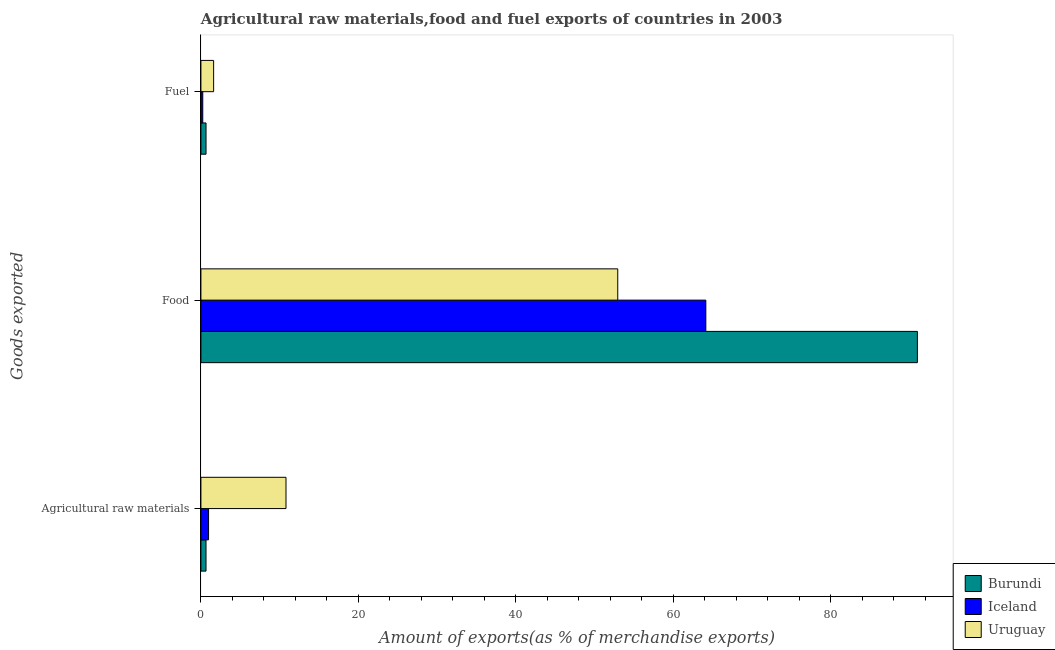How many groups of bars are there?
Provide a short and direct response. 3. How many bars are there on the 1st tick from the top?
Provide a succinct answer. 3. How many bars are there on the 3rd tick from the bottom?
Your response must be concise. 3. What is the label of the 1st group of bars from the top?
Offer a very short reply. Fuel. What is the percentage of fuel exports in Burundi?
Make the answer very short. 0.65. Across all countries, what is the maximum percentage of food exports?
Make the answer very short. 91.03. Across all countries, what is the minimum percentage of raw materials exports?
Provide a succinct answer. 0.65. In which country was the percentage of fuel exports maximum?
Your answer should be compact. Uruguay. In which country was the percentage of raw materials exports minimum?
Your response must be concise. Burundi. What is the total percentage of raw materials exports in the graph?
Make the answer very short. 12.43. What is the difference between the percentage of fuel exports in Uruguay and that in Burundi?
Your answer should be compact. 0.97. What is the difference between the percentage of fuel exports in Iceland and the percentage of raw materials exports in Uruguay?
Make the answer very short. -10.58. What is the average percentage of raw materials exports per country?
Make the answer very short. 4.14. What is the difference between the percentage of raw materials exports and percentage of fuel exports in Iceland?
Provide a succinct answer. 0.74. In how many countries, is the percentage of food exports greater than 84 %?
Give a very brief answer. 1. What is the ratio of the percentage of fuel exports in Iceland to that in Burundi?
Ensure brevity in your answer.  0.36. Is the percentage of raw materials exports in Burundi less than that in Uruguay?
Offer a very short reply. Yes. Is the difference between the percentage of fuel exports in Uruguay and Iceland greater than the difference between the percentage of food exports in Uruguay and Iceland?
Your answer should be very brief. Yes. What is the difference between the highest and the second highest percentage of fuel exports?
Provide a short and direct response. 0.97. What is the difference between the highest and the lowest percentage of food exports?
Make the answer very short. 38.07. What does the 3rd bar from the top in Fuel represents?
Keep it short and to the point. Burundi. What does the 1st bar from the bottom in Agricultural raw materials represents?
Give a very brief answer. Burundi. Is it the case that in every country, the sum of the percentage of raw materials exports and percentage of food exports is greater than the percentage of fuel exports?
Offer a very short reply. Yes. Are the values on the major ticks of X-axis written in scientific E-notation?
Make the answer very short. No. Does the graph contain any zero values?
Your response must be concise. No. How many legend labels are there?
Offer a terse response. 3. What is the title of the graph?
Make the answer very short. Agricultural raw materials,food and fuel exports of countries in 2003. Does "Cayman Islands" appear as one of the legend labels in the graph?
Your answer should be compact. No. What is the label or title of the X-axis?
Offer a very short reply. Amount of exports(as % of merchandise exports). What is the label or title of the Y-axis?
Ensure brevity in your answer.  Goods exported. What is the Amount of exports(as % of merchandise exports) in Burundi in Agricultural raw materials?
Make the answer very short. 0.65. What is the Amount of exports(as % of merchandise exports) of Iceland in Agricultural raw materials?
Make the answer very short. 0.97. What is the Amount of exports(as % of merchandise exports) of Uruguay in Agricultural raw materials?
Ensure brevity in your answer.  10.81. What is the Amount of exports(as % of merchandise exports) in Burundi in Food?
Offer a very short reply. 91.03. What is the Amount of exports(as % of merchandise exports) of Iceland in Food?
Offer a very short reply. 64.15. What is the Amount of exports(as % of merchandise exports) of Uruguay in Food?
Give a very brief answer. 52.96. What is the Amount of exports(as % of merchandise exports) in Burundi in Fuel?
Provide a succinct answer. 0.65. What is the Amount of exports(as % of merchandise exports) of Iceland in Fuel?
Your answer should be very brief. 0.23. What is the Amount of exports(as % of merchandise exports) in Uruguay in Fuel?
Your answer should be compact. 1.62. Across all Goods exported, what is the maximum Amount of exports(as % of merchandise exports) in Burundi?
Offer a very short reply. 91.03. Across all Goods exported, what is the maximum Amount of exports(as % of merchandise exports) in Iceland?
Provide a succinct answer. 64.15. Across all Goods exported, what is the maximum Amount of exports(as % of merchandise exports) of Uruguay?
Make the answer very short. 52.96. Across all Goods exported, what is the minimum Amount of exports(as % of merchandise exports) in Burundi?
Ensure brevity in your answer.  0.65. Across all Goods exported, what is the minimum Amount of exports(as % of merchandise exports) in Iceland?
Your answer should be very brief. 0.23. Across all Goods exported, what is the minimum Amount of exports(as % of merchandise exports) in Uruguay?
Your response must be concise. 1.62. What is the total Amount of exports(as % of merchandise exports) in Burundi in the graph?
Your answer should be very brief. 92.32. What is the total Amount of exports(as % of merchandise exports) in Iceland in the graph?
Give a very brief answer. 65.35. What is the total Amount of exports(as % of merchandise exports) of Uruguay in the graph?
Make the answer very short. 65.38. What is the difference between the Amount of exports(as % of merchandise exports) of Burundi in Agricultural raw materials and that in Food?
Give a very brief answer. -90.38. What is the difference between the Amount of exports(as % of merchandise exports) of Iceland in Agricultural raw materials and that in Food?
Give a very brief answer. -63.18. What is the difference between the Amount of exports(as % of merchandise exports) of Uruguay in Agricultural raw materials and that in Food?
Provide a short and direct response. -42.15. What is the difference between the Amount of exports(as % of merchandise exports) of Burundi in Agricultural raw materials and that in Fuel?
Offer a terse response. -0. What is the difference between the Amount of exports(as % of merchandise exports) in Iceland in Agricultural raw materials and that in Fuel?
Make the answer very short. 0.74. What is the difference between the Amount of exports(as % of merchandise exports) in Uruguay in Agricultural raw materials and that in Fuel?
Give a very brief answer. 9.19. What is the difference between the Amount of exports(as % of merchandise exports) in Burundi in Food and that in Fuel?
Offer a very short reply. 90.38. What is the difference between the Amount of exports(as % of merchandise exports) of Iceland in Food and that in Fuel?
Offer a terse response. 63.91. What is the difference between the Amount of exports(as % of merchandise exports) of Uruguay in Food and that in Fuel?
Offer a very short reply. 51.34. What is the difference between the Amount of exports(as % of merchandise exports) of Burundi in Agricultural raw materials and the Amount of exports(as % of merchandise exports) of Iceland in Food?
Provide a short and direct response. -63.5. What is the difference between the Amount of exports(as % of merchandise exports) of Burundi in Agricultural raw materials and the Amount of exports(as % of merchandise exports) of Uruguay in Food?
Your answer should be compact. -52.31. What is the difference between the Amount of exports(as % of merchandise exports) of Iceland in Agricultural raw materials and the Amount of exports(as % of merchandise exports) of Uruguay in Food?
Keep it short and to the point. -51.99. What is the difference between the Amount of exports(as % of merchandise exports) of Burundi in Agricultural raw materials and the Amount of exports(as % of merchandise exports) of Iceland in Fuel?
Keep it short and to the point. 0.41. What is the difference between the Amount of exports(as % of merchandise exports) of Burundi in Agricultural raw materials and the Amount of exports(as % of merchandise exports) of Uruguay in Fuel?
Provide a succinct answer. -0.97. What is the difference between the Amount of exports(as % of merchandise exports) of Iceland in Agricultural raw materials and the Amount of exports(as % of merchandise exports) of Uruguay in Fuel?
Provide a succinct answer. -0.64. What is the difference between the Amount of exports(as % of merchandise exports) of Burundi in Food and the Amount of exports(as % of merchandise exports) of Iceland in Fuel?
Give a very brief answer. 90.79. What is the difference between the Amount of exports(as % of merchandise exports) in Burundi in Food and the Amount of exports(as % of merchandise exports) in Uruguay in Fuel?
Provide a short and direct response. 89.41. What is the difference between the Amount of exports(as % of merchandise exports) of Iceland in Food and the Amount of exports(as % of merchandise exports) of Uruguay in Fuel?
Your answer should be very brief. 62.53. What is the average Amount of exports(as % of merchandise exports) in Burundi per Goods exported?
Provide a short and direct response. 30.77. What is the average Amount of exports(as % of merchandise exports) of Iceland per Goods exported?
Your answer should be compact. 21.78. What is the average Amount of exports(as % of merchandise exports) in Uruguay per Goods exported?
Your answer should be very brief. 21.8. What is the difference between the Amount of exports(as % of merchandise exports) in Burundi and Amount of exports(as % of merchandise exports) in Iceland in Agricultural raw materials?
Your answer should be very brief. -0.32. What is the difference between the Amount of exports(as % of merchandise exports) in Burundi and Amount of exports(as % of merchandise exports) in Uruguay in Agricultural raw materials?
Provide a succinct answer. -10.16. What is the difference between the Amount of exports(as % of merchandise exports) of Iceland and Amount of exports(as % of merchandise exports) of Uruguay in Agricultural raw materials?
Make the answer very short. -9.84. What is the difference between the Amount of exports(as % of merchandise exports) of Burundi and Amount of exports(as % of merchandise exports) of Iceland in Food?
Give a very brief answer. 26.88. What is the difference between the Amount of exports(as % of merchandise exports) in Burundi and Amount of exports(as % of merchandise exports) in Uruguay in Food?
Keep it short and to the point. 38.07. What is the difference between the Amount of exports(as % of merchandise exports) of Iceland and Amount of exports(as % of merchandise exports) of Uruguay in Food?
Give a very brief answer. 11.19. What is the difference between the Amount of exports(as % of merchandise exports) in Burundi and Amount of exports(as % of merchandise exports) in Iceland in Fuel?
Your answer should be compact. 0.41. What is the difference between the Amount of exports(as % of merchandise exports) in Burundi and Amount of exports(as % of merchandise exports) in Uruguay in Fuel?
Offer a very short reply. -0.97. What is the difference between the Amount of exports(as % of merchandise exports) in Iceland and Amount of exports(as % of merchandise exports) in Uruguay in Fuel?
Offer a very short reply. -1.38. What is the ratio of the Amount of exports(as % of merchandise exports) of Burundi in Agricultural raw materials to that in Food?
Your response must be concise. 0.01. What is the ratio of the Amount of exports(as % of merchandise exports) of Iceland in Agricultural raw materials to that in Food?
Provide a short and direct response. 0.02. What is the ratio of the Amount of exports(as % of merchandise exports) of Uruguay in Agricultural raw materials to that in Food?
Your response must be concise. 0.2. What is the ratio of the Amount of exports(as % of merchandise exports) in Iceland in Agricultural raw materials to that in Fuel?
Your answer should be very brief. 4.14. What is the ratio of the Amount of exports(as % of merchandise exports) of Uruguay in Agricultural raw materials to that in Fuel?
Your answer should be very brief. 6.69. What is the ratio of the Amount of exports(as % of merchandise exports) in Burundi in Food to that in Fuel?
Your answer should be compact. 140.2. What is the ratio of the Amount of exports(as % of merchandise exports) of Iceland in Food to that in Fuel?
Give a very brief answer. 273.42. What is the ratio of the Amount of exports(as % of merchandise exports) of Uruguay in Food to that in Fuel?
Provide a short and direct response. 32.78. What is the difference between the highest and the second highest Amount of exports(as % of merchandise exports) of Burundi?
Keep it short and to the point. 90.38. What is the difference between the highest and the second highest Amount of exports(as % of merchandise exports) of Iceland?
Make the answer very short. 63.18. What is the difference between the highest and the second highest Amount of exports(as % of merchandise exports) in Uruguay?
Your answer should be very brief. 42.15. What is the difference between the highest and the lowest Amount of exports(as % of merchandise exports) of Burundi?
Give a very brief answer. 90.38. What is the difference between the highest and the lowest Amount of exports(as % of merchandise exports) in Iceland?
Ensure brevity in your answer.  63.91. What is the difference between the highest and the lowest Amount of exports(as % of merchandise exports) of Uruguay?
Ensure brevity in your answer.  51.34. 